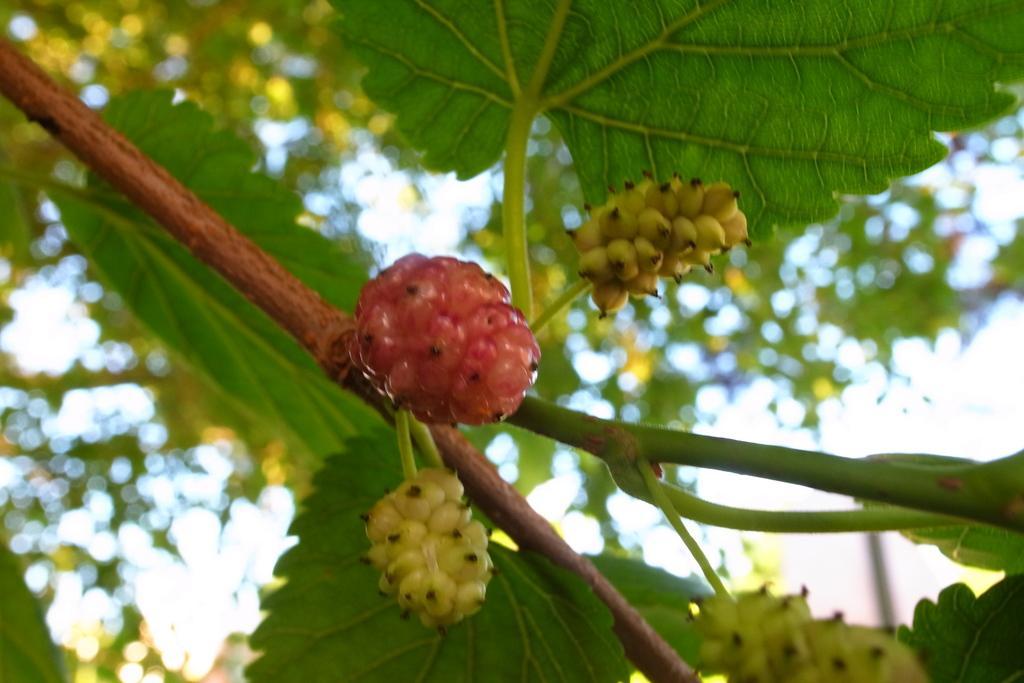What is the main subject of the image? The main subject of the image is a branch of a tree. What can be observed on the branch? The branch has leaves and fruits. How would you describe the background of the image? The background of the image is blurry. How does the branch control the need for a tent in the image? The branch does not control the need for a tent, as there is no tent present in the image. 